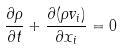<formula> <loc_0><loc_0><loc_500><loc_500>\frac { \partial \rho } { \partial t } + \frac { \partial ( \rho v _ { i } ) } { \partial x _ { i } } = 0</formula> 